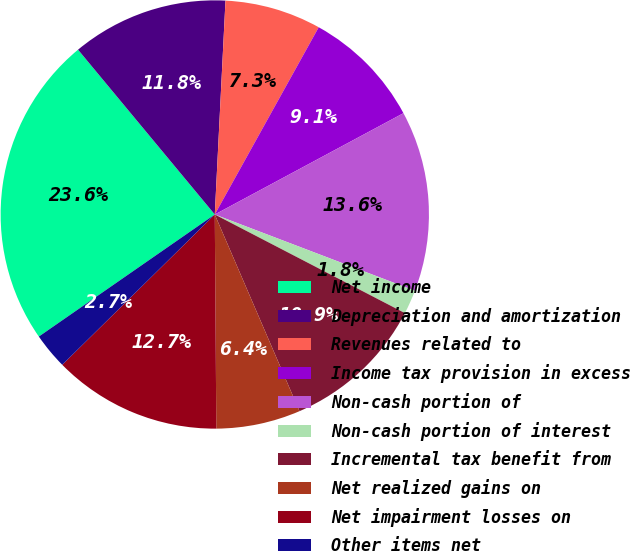Convert chart to OTSL. <chart><loc_0><loc_0><loc_500><loc_500><pie_chart><fcel>Net income<fcel>Depreciation and amortization<fcel>Revenues related to<fcel>Income tax provision in excess<fcel>Non-cash portion of<fcel>Non-cash portion of interest<fcel>Incremental tax benefit from<fcel>Net realized gains on<fcel>Net impairment losses on<fcel>Other items net<nl><fcel>23.63%<fcel>11.82%<fcel>7.27%<fcel>9.09%<fcel>13.64%<fcel>1.82%<fcel>10.91%<fcel>6.36%<fcel>12.73%<fcel>2.73%<nl></chart> 